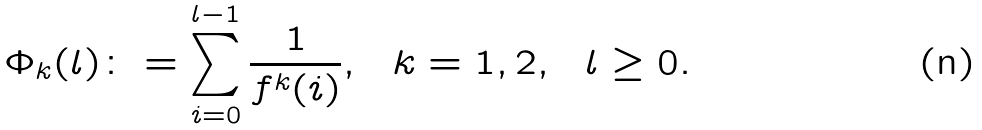Convert formula to latex. <formula><loc_0><loc_0><loc_500><loc_500>\Phi _ { k } ( l ) \colon = \sum _ { i = 0 } ^ { l - 1 } \frac { 1 } { f ^ { k } ( i ) } , \ \ k = 1 , 2 , \ \ l \geq 0 .</formula> 